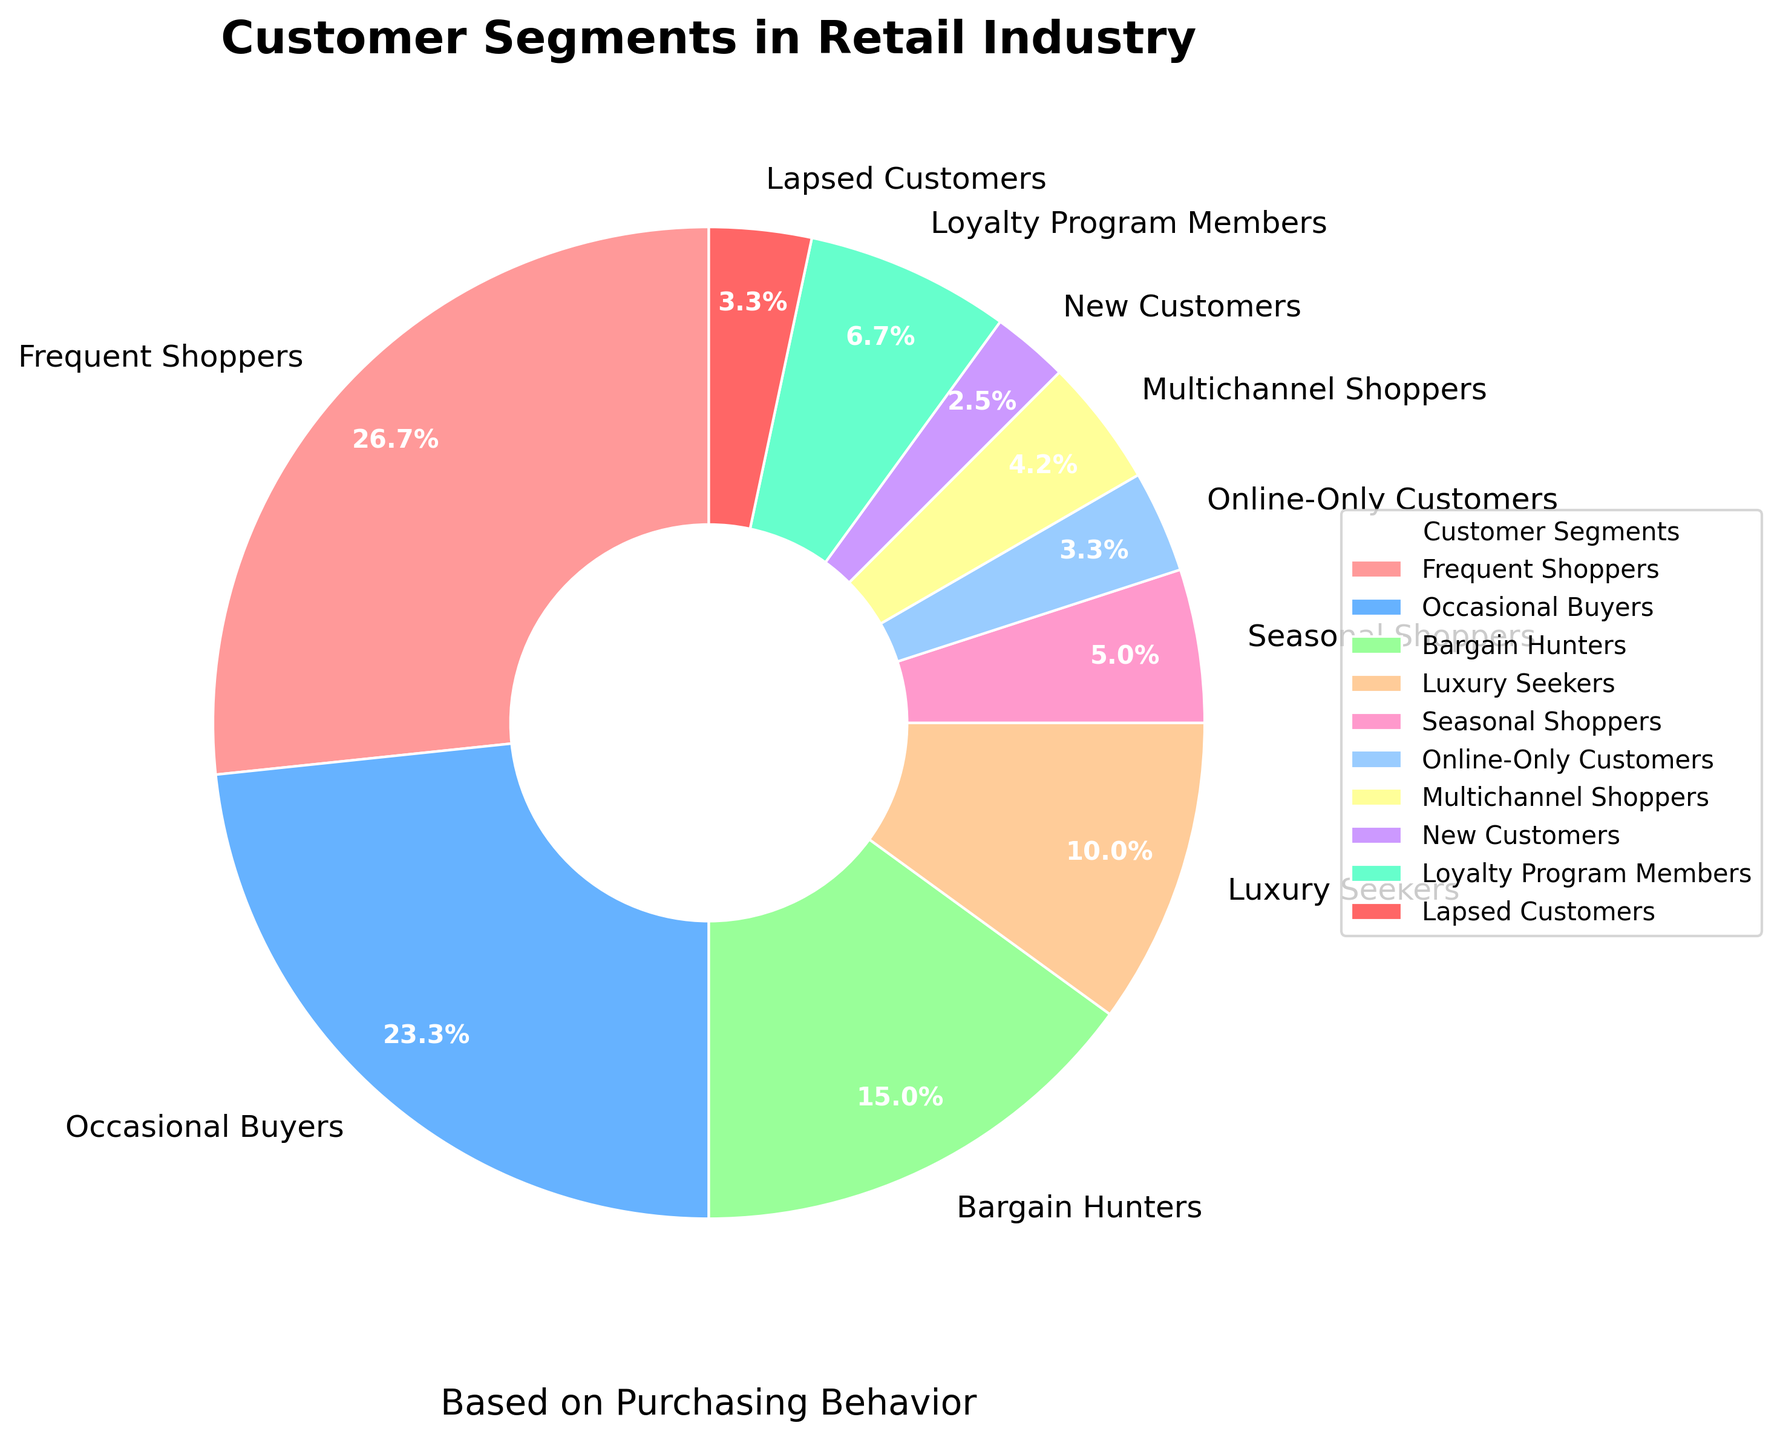What customer segment has the highest proportion? The segment with the largest wedge is "Frequent Shoppers," which is indicated as 32% by the label on the segment.
Answer: Frequent Shoppers Which customer segment has the smallest proportion? The smallest wedge corresponds to "New Customers," labeled as 3%.
Answer: New Customers What is the combined proportion of "Frequent Shoppers" and "Occasional Buyers"? Summing the proportions of Frequent Shoppers (32%) and Occasional Buyers (28%) gives 32 + 28 = 60%.
Answer: 60% Compare the proportions of "Bargain Hunters" and "Luxury Seekers." Which is higher and by how much? Bargain Hunters have a proportion of 18%, and Luxury Seekers have 12%. The difference is 18 - 12 = 6%.
Answer: Bargain Hunters by 6% What is the sum of the proportions for "Online-Only Customers," "Multichannel Shoppers," and "New Customers"? Online-Only Customers (4%), Multichannel Shoppers (5%), and New Customers (3%). Summing them gives 4 + 5 + 3 = 12%.
Answer: 12% Considering "Loyalty Program Members" and "Lapsed Customers," is the proportion of "Loyalty Program Members" more than double that of "Lapsed Customers"? Loyalty Program Members have 8% and Lapsed Customers have 4%. 8% is exactly double 4%, so the proportion of Loyalty Program Members is not more than double Lapsed Customers.
Answer: No What color represents the "Frequent Shoppers" segment? The "Frequent Shoppers" slice is colored red in the pie chart.
Answer: Red Which segments combined equal the proportion of "Frequent Shoppers"? Combined proportions that equal 32% include "Occasional Buyers" (28%) and "Online-Only Customers" (4%), summing to 28 + 4 = 32%.
Answer: Occasional Buyers and Online-Only Customers Which is larger: the sum of "Luxury Seekers" and "Seasonal Shoppers" or the proportion of "Occasional Buyers"? Luxury Seekers (12%) + Seasonal Shoppers (6%) = 18% which is less than Occasional Buyers' proportion of 28%.
Answer: Occasional Buyers Which customer segments have proportions less than 5%? The segments with proportions less than 5% include "Online-Only Customers" (4%), "Multichannel Shoppers" (5%), "New Customers" (3%), and "Lapsed Customers" (4%).
Answer: Online-Only Customers, New Customers, Lapsed Customers 